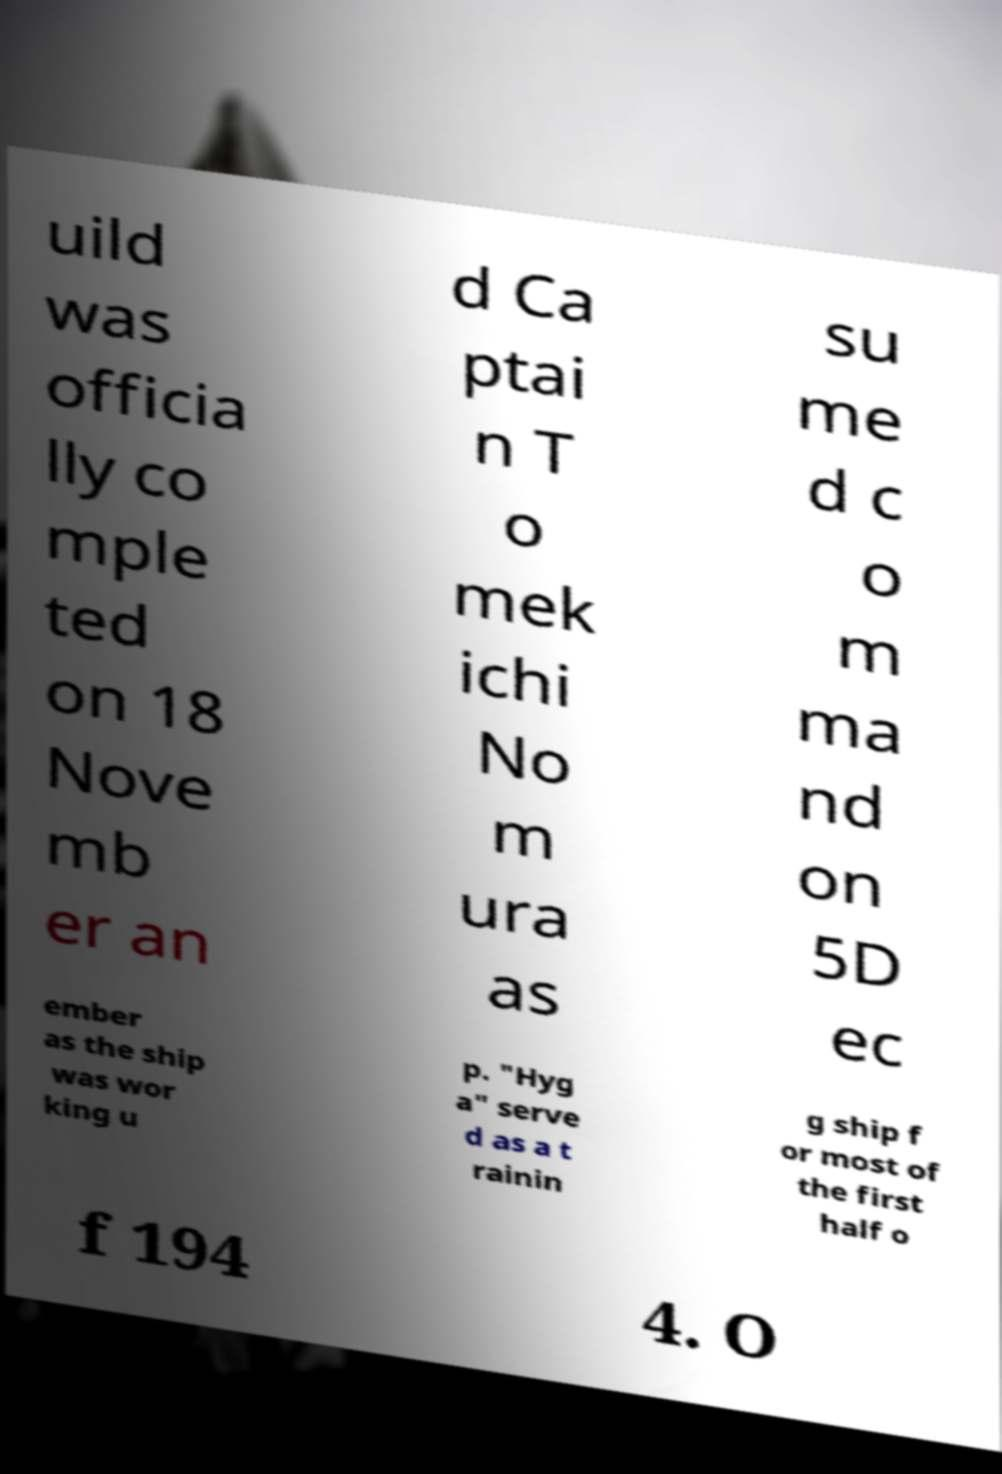There's text embedded in this image that I need extracted. Can you transcribe it verbatim? uild was officia lly co mple ted on 18 Nove mb er an d Ca ptai n T o mek ichi No m ura as su me d c o m ma nd on 5D ec ember as the ship was wor king u p. "Hyg a" serve d as a t rainin g ship f or most of the first half o f 194 4. O 